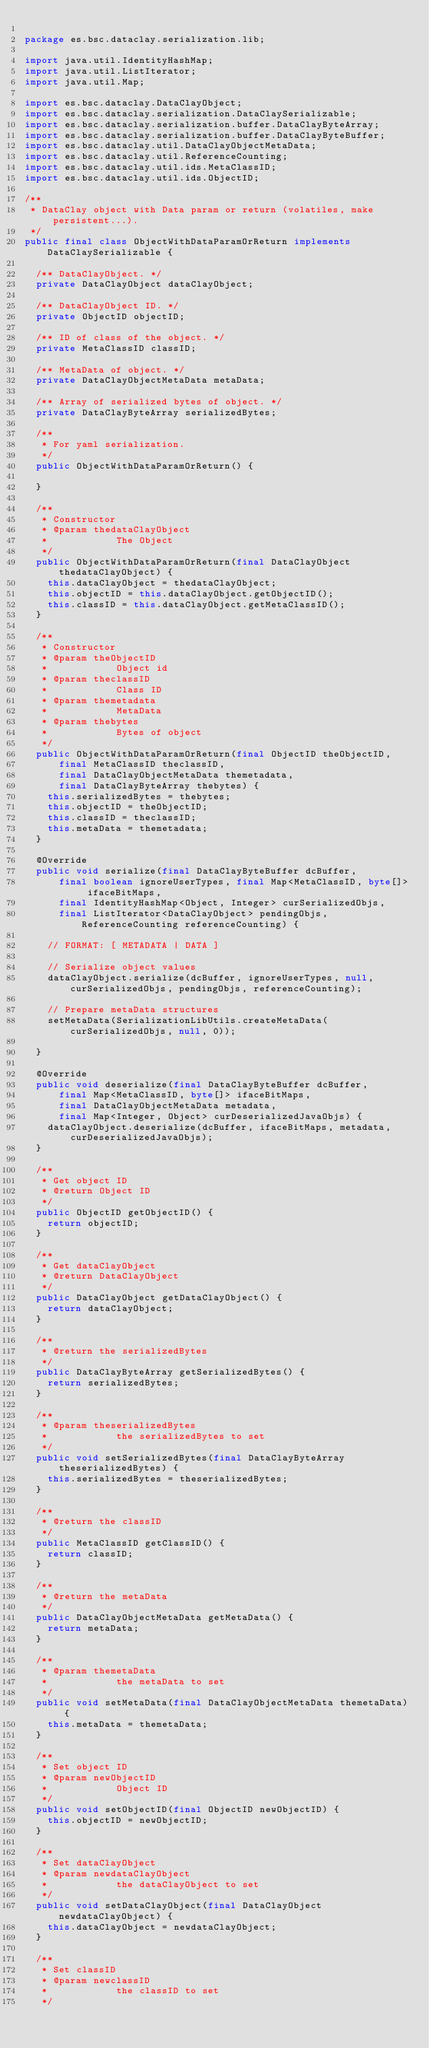<code> <loc_0><loc_0><loc_500><loc_500><_Java_>
package es.bsc.dataclay.serialization.lib;

import java.util.IdentityHashMap;
import java.util.ListIterator;
import java.util.Map;

import es.bsc.dataclay.DataClayObject;
import es.bsc.dataclay.serialization.DataClaySerializable;
import es.bsc.dataclay.serialization.buffer.DataClayByteArray;
import es.bsc.dataclay.serialization.buffer.DataClayByteBuffer;
import es.bsc.dataclay.util.DataClayObjectMetaData;
import es.bsc.dataclay.util.ReferenceCounting;
import es.bsc.dataclay.util.ids.MetaClassID;
import es.bsc.dataclay.util.ids.ObjectID;

/**
 * DataClay object with Data param or return (volatiles, make persistent...).
 */
public final class ObjectWithDataParamOrReturn implements DataClaySerializable {

	/** DataClayObject. */
	private DataClayObject dataClayObject;

	/** DataClayObject ID. */
	private ObjectID objectID;

	/** ID of class of the object. */
	private MetaClassID classID;

	/** MetaData of object. */
	private DataClayObjectMetaData metaData;

	/** Array of serialized bytes of object. */
	private DataClayByteArray serializedBytes;

	/**
	 * For yaml serialization.
	 */
	public ObjectWithDataParamOrReturn() {

	}

	/**
	 * Constructor
	 * @param thedataClayObject
	 *            The Object
	 */
	public ObjectWithDataParamOrReturn(final DataClayObject thedataClayObject) {
		this.dataClayObject = thedataClayObject;
		this.objectID = this.dataClayObject.getObjectID();
		this.classID = this.dataClayObject.getMetaClassID();
	}

	/**
	 * Constructor
	 * @param theObjectID
	 *            Object id
	 * @param theclassID
	 *            Class ID
	 * @param themetadata
	 *            MetaData
	 * @param thebytes
	 *            Bytes of object
	 */
	public ObjectWithDataParamOrReturn(final ObjectID theObjectID,
			final MetaClassID theclassID,
			final DataClayObjectMetaData themetadata,
			final DataClayByteArray thebytes) {
		this.serializedBytes = thebytes;
		this.objectID = theObjectID;
		this.classID = theclassID;
		this.metaData = themetadata;
	}

	@Override
	public void serialize(final DataClayByteBuffer dcBuffer,
			final boolean ignoreUserTypes, final Map<MetaClassID, byte[]> ifaceBitMaps,
			final IdentityHashMap<Object, Integer> curSerializedObjs,
			final ListIterator<DataClayObject> pendingObjs, ReferenceCounting referenceCounting) {

		// FORMAT: [ METADATA | DATA ]

		// Serialize object values
		dataClayObject.serialize(dcBuffer, ignoreUserTypes, null, curSerializedObjs, pendingObjs, referenceCounting);

		// Prepare metaData structures
		setMetaData(SerializationLibUtils.createMetaData(curSerializedObjs, null, 0));

	}

	@Override
	public void deserialize(final DataClayByteBuffer dcBuffer,
			final Map<MetaClassID, byte[]> ifaceBitMaps,
			final DataClayObjectMetaData metadata,
			final Map<Integer, Object> curDeserializedJavaObjs) {
		dataClayObject.deserialize(dcBuffer, ifaceBitMaps, metadata, curDeserializedJavaObjs);
	}

	/**
	 * Get object ID
	 * @return Object ID
	 */
	public ObjectID getObjectID() {
		return objectID;
	}

	/**
	 * Get dataClayObject
	 * @return DataClayObject
	 */
	public DataClayObject getDataClayObject() {
		return dataClayObject;
	}

	/**
	 * @return the serializedBytes
	 */
	public DataClayByteArray getSerializedBytes() {
		return serializedBytes;
	}

	/**
	 * @param theserializedBytes
	 *            the serializedBytes to set
	 */
	public void setSerializedBytes(final DataClayByteArray theserializedBytes) {
		this.serializedBytes = theserializedBytes;
	}

	/**
	 * @return the classID
	 */
	public MetaClassID getClassID() {
		return classID;
	}

	/**
	 * @return the metaData
	 */
	public DataClayObjectMetaData getMetaData() {
		return metaData;
	}

	/**
	 * @param themetaData
	 *            the metaData to set
	 */
	public void setMetaData(final DataClayObjectMetaData themetaData) {
		this.metaData = themetaData;
	}

	/**
	 * Set object ID
	 * @param newObjectID
	 *            Object ID
	 */
	public void setObjectID(final ObjectID newObjectID) {
		this.objectID = newObjectID;
	}

	/**
	 * Set dataClayObject
	 * @param newdataClayObject
	 *            the dataClayObject to set
	 */
	public void setDataClayObject(final DataClayObject newdataClayObject) {
		this.dataClayObject = newdataClayObject;
	}

	/**
	 * Set classID
	 * @param newclassID
	 *            the classID to set
	 */</code> 